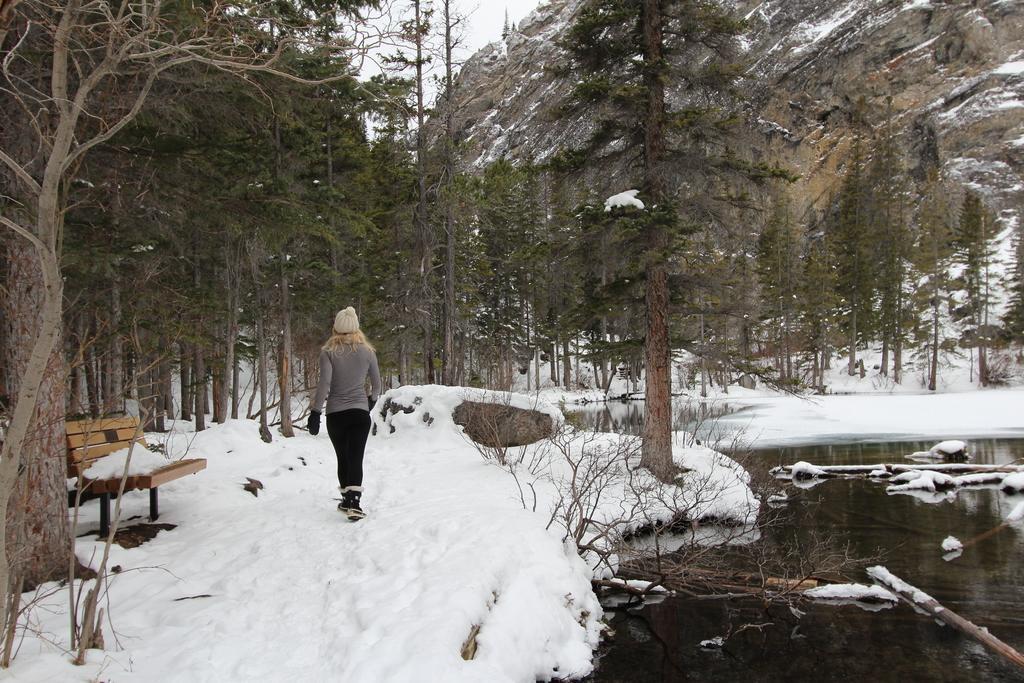Please provide a concise description of this image. This is a picture of hill station and there are some trees in front of the hill station. And there a bench in the ground and there is a woman walking on the ground. And there is a lake beside the road. and a snow fall on the road. 